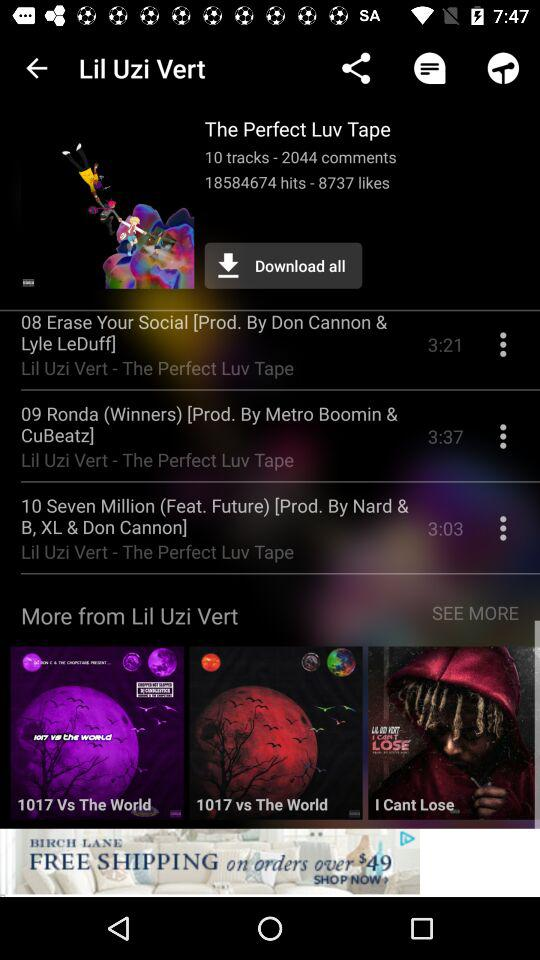How many tracks are in this? There are 10 tracks. 